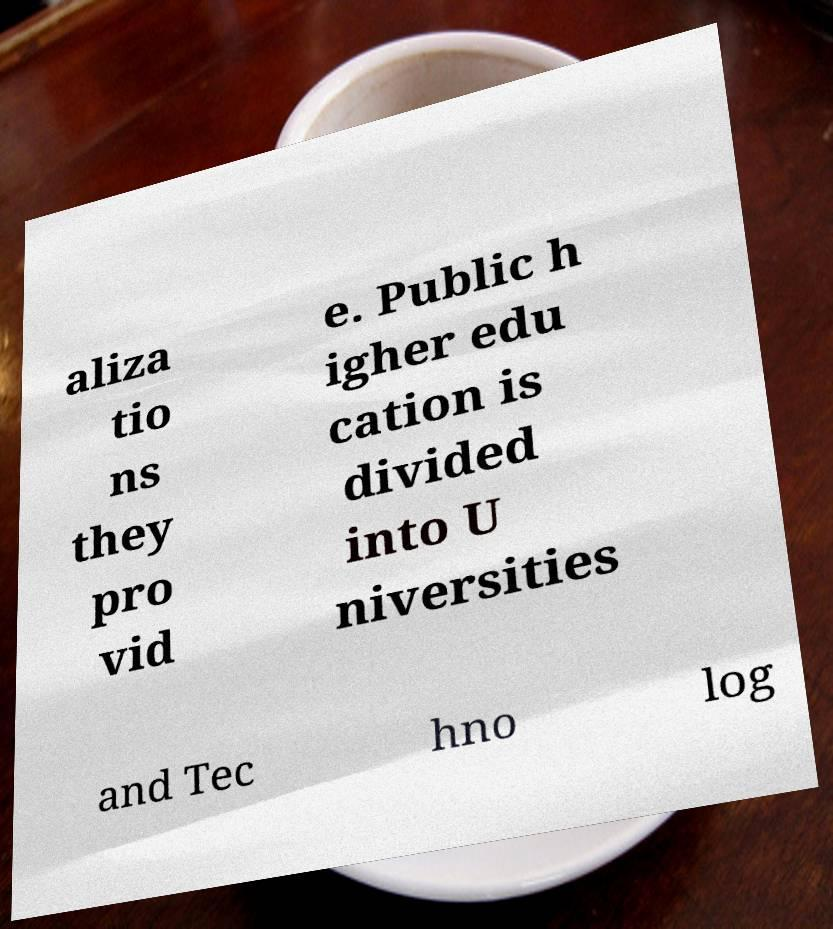Can you read and provide the text displayed in the image?This photo seems to have some interesting text. Can you extract and type it out for me? aliza tio ns they pro vid e. Public h igher edu cation is divided into U niversities and Tec hno log 